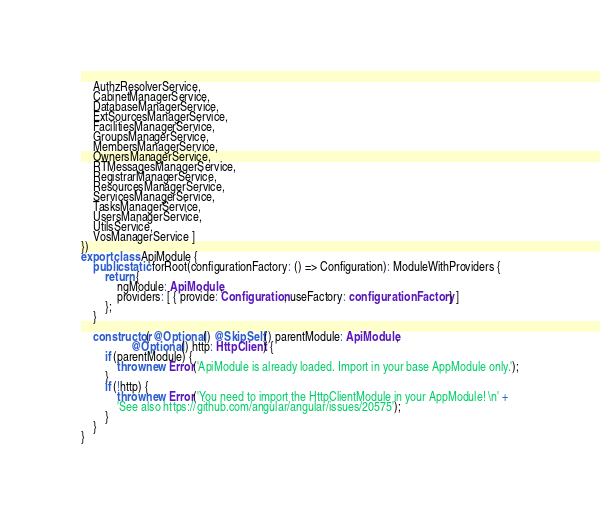Convert code to text. <code><loc_0><loc_0><loc_500><loc_500><_TypeScript_>    AuthzResolverService,
    CabinetManagerService,
    DatabaseManagerService,
    ExtSourcesManagerService,
    FacilitiesManagerService,
    GroupsManagerService,
    MembersManagerService,
    OwnersManagerService,
    RTMessagesManagerService,
    RegistrarManagerService,
    ResourcesManagerService,
    ServicesManagerService,
    TasksManagerService,
    UsersManagerService,
    UtilsService,
    VosManagerService ]
})
export class ApiModule {
    public static forRoot(configurationFactory: () => Configuration): ModuleWithProviders {
        return {
            ngModule: ApiModule,
            providers: [ { provide: Configuration, useFactory: configurationFactory } ]
        };
    }

    constructor( @Optional() @SkipSelf() parentModule: ApiModule,
                 @Optional() http: HttpClient) {
        if (parentModule) {
            throw new Error('ApiModule is already loaded. Import in your base AppModule only.');
        }
        if (!http) {
            throw new Error('You need to import the HttpClientModule in your AppModule! \n' +
            'See also https://github.com/angular/angular/issues/20575');
        }
    }
}
</code> 